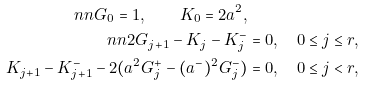<formula> <loc_0><loc_0><loc_500><loc_500>\ n n G _ { 0 } = 1 , \quad K _ { 0 } = 2 a ^ { 2 } , \\ \ n n 2 G _ { j + 1 } - K _ { j } - K _ { j } ^ { - } & = 0 , \quad 0 \leq j \leq r , \\ K _ { j + 1 } - K _ { j + 1 } ^ { - } - 2 ( a ^ { 2 } G _ { j } ^ { + } - ( a ^ { - } ) ^ { 2 } G _ { j } ^ { - } ) & = 0 , \quad 0 \leq j < r ,</formula> 